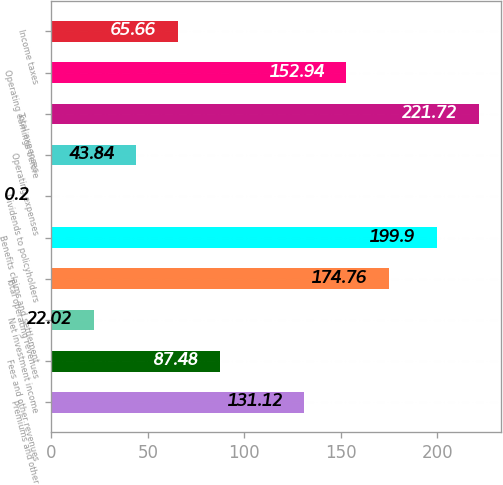<chart> <loc_0><loc_0><loc_500><loc_500><bar_chart><fcel>Premiums and other<fcel>Fees and other revenues<fcel>Net investment income<fcel>Total operating revenues<fcel>Benefits claims and settlement<fcel>Dividends to policyholders<fcel>Operating expenses<fcel>Total expenses<fcel>Operating earnings before<fcel>Income taxes<nl><fcel>131.12<fcel>87.48<fcel>22.02<fcel>174.76<fcel>199.9<fcel>0.2<fcel>43.84<fcel>221.72<fcel>152.94<fcel>65.66<nl></chart> 